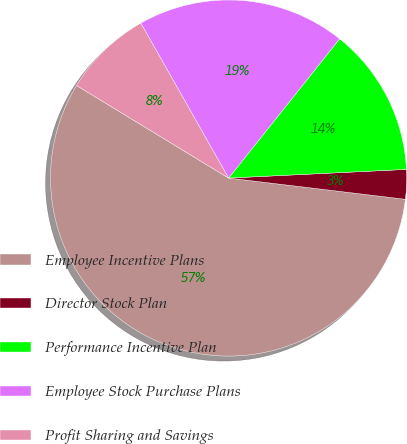Convert chart. <chart><loc_0><loc_0><loc_500><loc_500><pie_chart><fcel>Employee Incentive Plans<fcel>Director Stock Plan<fcel>Performance Incentive Plan<fcel>Employee Stock Purchase Plans<fcel>Profit Sharing and Savings<nl><fcel>56.8%<fcel>2.68%<fcel>13.51%<fcel>18.92%<fcel>8.09%<nl></chart> 